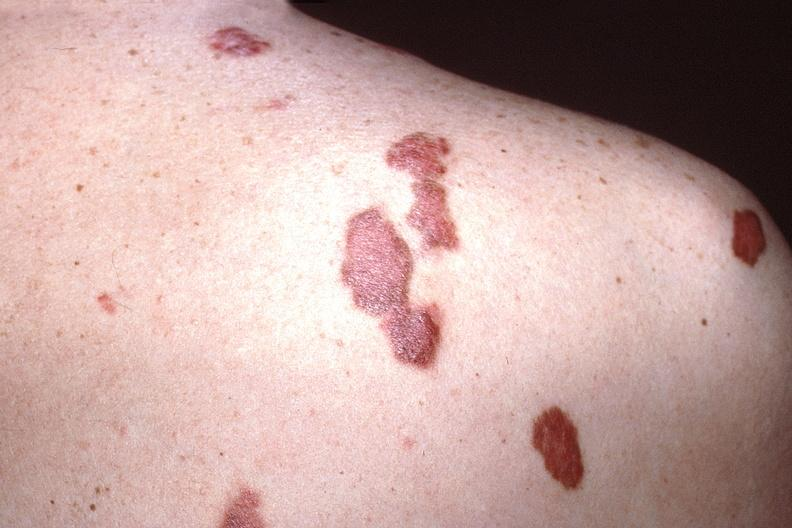does this image show skin, kaposis 's sarcoma?
Answer the question using a single word or phrase. Yes 